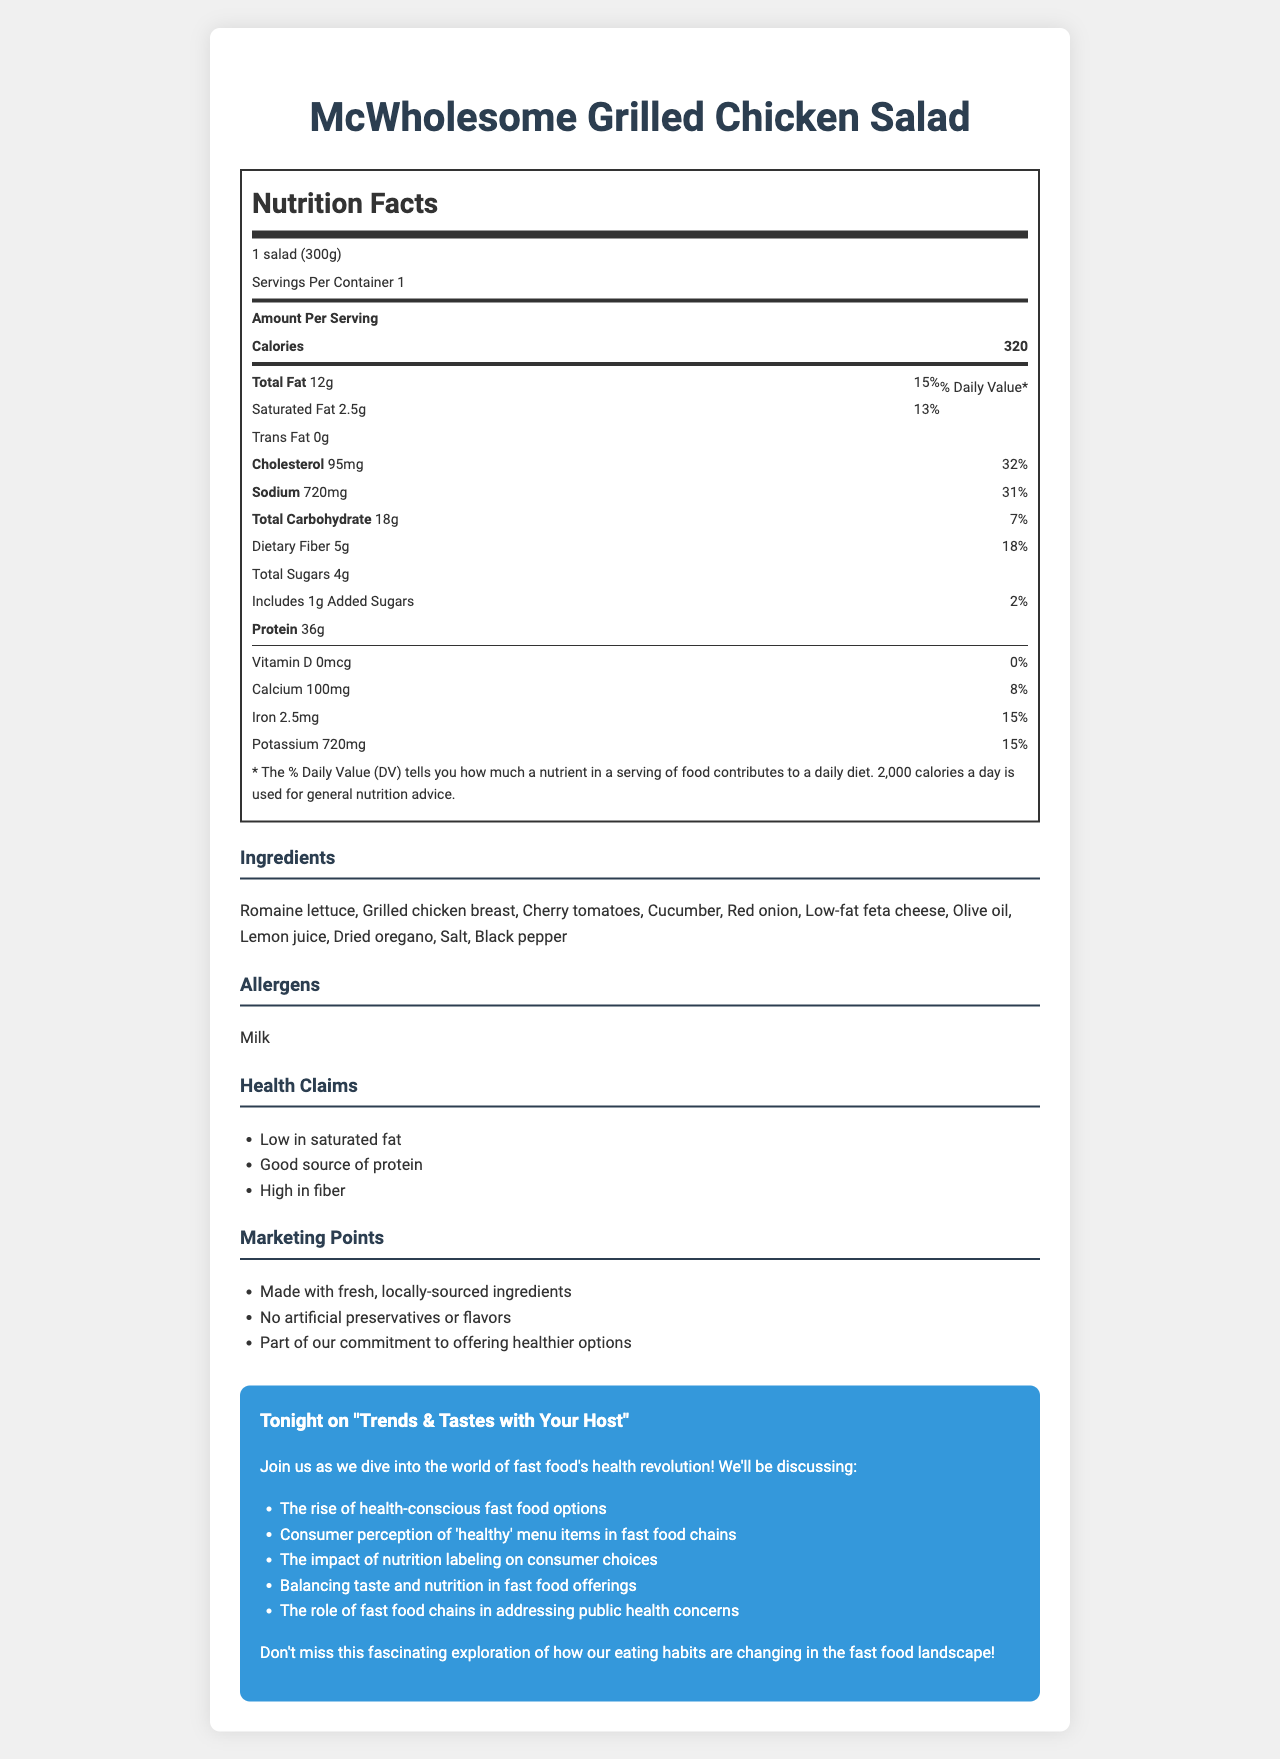what is the serving size for the McWholesome Grilled Chicken Salad? The serving size is mentioned at the beginning of the nutrition label.
Answer: 1 salad (300g) how many calories are in one serving of the McWholesome Grilled Chicken Salad? It is stated directly next to the "Calories" label on the nutrition facts section.
Answer: 320 what is the percentage of daily value for sodium? The document shows the sodium content and its corresponding daily value percentage.
Answer: 31% what are the main ingredients in this salad? The ingredients list is shown clearly under the "Ingredients" section.
Answer: Romaine lettuce, Grilled chicken breast, Cherry tomatoes, Cucumber, Red onion, Low-fat feta cheese, Olive oil, Lemon juice, Dried oregano, Salt, Black pepper how much protein does the McWholesome Grilled Chicken Salad have? The amount of protein is listed under the nutrient facts.
Answer: 36g how is the McWholesome Grilled Chicken Salad described in the marketing points? A. Low-calorie B. Made with fresh, locally-sourced ingredients C. Contains artificial preservatives D. Gluten-free The marketing points mention that the salad is made with fresh, locally-sourced ingredients.
Answer: B which nutrient has the lowest daily value percentage in this salad? A. Calcium B. Iron C. Vitamin D D. Dietary Fiber Vitamin D has a daily value percentage of 0%.
Answer: C does the McWholesome Grilled Chicken Salad contain trans fat? The nutrition label specifies that the amount of trans fat is 0g.
Answer: No summarize the content of the McWholesome Grilled Chicken Salad label. The document includes detailed nutritional information, a list of ingredients, health claims, and marketing points that emphasize the salad is a healthier choice with no artificial additives.
Answer: The McWholesome Grilled Chicken Salad is a health-conscious menu item from a fast-food chain, with a serving size of 1 salad (300g). It contains 320 calories and significant amounts of protein, fiber, and other nutrients like calcium and potassium. It claims to be low in saturated fat and made with fresh, locally-sourced ingredients without artificial preservatives or flavors. The label also lists ingredients and health claims, highlighting its appeal as a healthier fast food option. what is the trend discussed in relation to the McWholesome Grilled Chicken Salad and fast food? The discussion topics include this trend, reflecting the broader movement towards healthier menu items in fast food chains.
Answer: The rise of health-conscious fast food options what is the source of the dietary fiber in the salad? The document does not specify which ingredients are contributing the dietary fiber.
Answer: Cannot be determined what allergens are present in the McWholesome Grilled Chicken Salad? The allergens section explicitly mentions the presence of milk.
Answer: Milk 